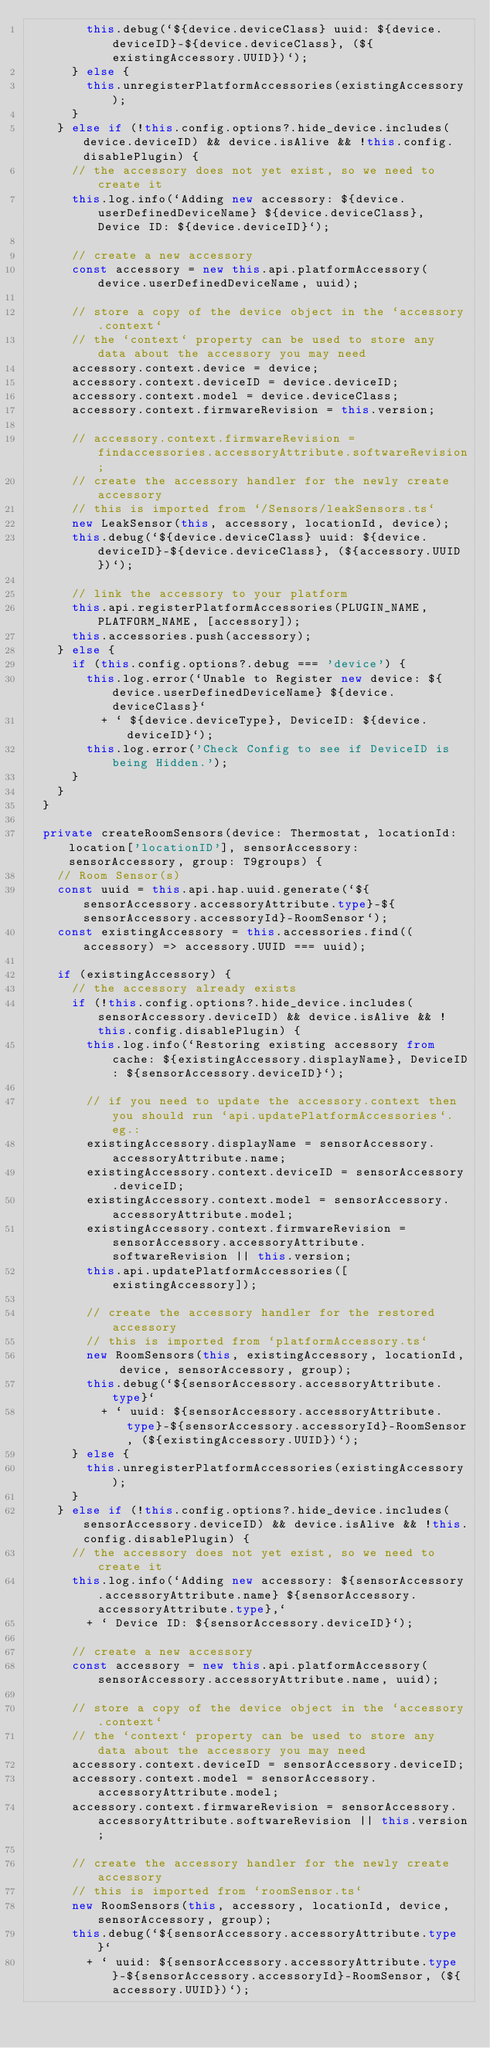<code> <loc_0><loc_0><loc_500><loc_500><_TypeScript_>        this.debug(`${device.deviceClass} uuid: ${device.deviceID}-${device.deviceClass}, (${existingAccessory.UUID})`);
      } else {
        this.unregisterPlatformAccessories(existingAccessory);
      }
    } else if (!this.config.options?.hide_device.includes(device.deviceID) && device.isAlive && !this.config.disablePlugin) {
      // the accessory does not yet exist, so we need to create it
      this.log.info(`Adding new accessory: ${device.userDefinedDeviceName} ${device.deviceClass}, Device ID: ${device.deviceID}`);

      // create a new accessory
      const accessory = new this.api.platformAccessory(device.userDefinedDeviceName, uuid);

      // store a copy of the device object in the `accessory.context`
      // the `context` property can be used to store any data about the accessory you may need
      accessory.context.device = device;
      accessory.context.deviceID = device.deviceID;
      accessory.context.model = device.deviceClass;
      accessory.context.firmwareRevision = this.version;

      // accessory.context.firmwareRevision = findaccessories.accessoryAttribute.softwareRevision;
      // create the accessory handler for the newly create accessory
      // this is imported from `/Sensors/leakSensors.ts`
      new LeakSensor(this, accessory, locationId, device);
      this.debug(`${device.deviceClass} uuid: ${device.deviceID}-${device.deviceClass}, (${accessory.UUID})`);

      // link the accessory to your platform
      this.api.registerPlatformAccessories(PLUGIN_NAME, PLATFORM_NAME, [accessory]);
      this.accessories.push(accessory);
    } else {
      if (this.config.options?.debug === 'device') {
        this.log.error(`Unable to Register new device: ${device.userDefinedDeviceName} ${device.deviceClass}`
          + ` ${device.deviceType}, DeviceID: ${device.deviceID}`);
        this.log.error('Check Config to see if DeviceID is being Hidden.');
      }
    }
  }

  private createRoomSensors(device: Thermostat, locationId: location['locationID'], sensorAccessory: sensorAccessory, group: T9groups) {
    // Room Sensor(s)
    const uuid = this.api.hap.uuid.generate(`${sensorAccessory.accessoryAttribute.type}-${sensorAccessory.accessoryId}-RoomSensor`);
    const existingAccessory = this.accessories.find((accessory) => accessory.UUID === uuid);

    if (existingAccessory) {
      // the accessory already exists
      if (!this.config.options?.hide_device.includes(sensorAccessory.deviceID) && device.isAlive && !this.config.disablePlugin) {
        this.log.info(`Restoring existing accessory from cache: ${existingAccessory.displayName}, DeviceID: ${sensorAccessory.deviceID}`);

        // if you need to update the accessory.context then you should run `api.updatePlatformAccessories`. eg.:
        existingAccessory.displayName = sensorAccessory.accessoryAttribute.name;
        existingAccessory.context.deviceID = sensorAccessory.deviceID;
        existingAccessory.context.model = sensorAccessory.accessoryAttribute.model;
        existingAccessory.context.firmwareRevision = sensorAccessory.accessoryAttribute.softwareRevision || this.version;
        this.api.updatePlatformAccessories([existingAccessory]);

        // create the accessory handler for the restored accessory
        // this is imported from `platformAccessory.ts`
        new RoomSensors(this, existingAccessory, locationId, device, sensorAccessory, group);
        this.debug(`${sensorAccessory.accessoryAttribute.type}`
          + ` uuid: ${sensorAccessory.accessoryAttribute.type}-${sensorAccessory.accessoryId}-RoomSensor, (${existingAccessory.UUID})`);
      } else {
        this.unregisterPlatformAccessories(existingAccessory);
      }
    } else if (!this.config.options?.hide_device.includes(sensorAccessory.deviceID) && device.isAlive && !this.config.disablePlugin) {
      // the accessory does not yet exist, so we need to create it
      this.log.info(`Adding new accessory: ${sensorAccessory.accessoryAttribute.name} ${sensorAccessory.accessoryAttribute.type},`
        + ` Device ID: ${sensorAccessory.deviceID}`);

      // create a new accessory
      const accessory = new this.api.platformAccessory(sensorAccessory.accessoryAttribute.name, uuid);

      // store a copy of the device object in the `accessory.context`
      // the `context` property can be used to store any data about the accessory you may need
      accessory.context.deviceID = sensorAccessory.deviceID;
      accessory.context.model = sensorAccessory.accessoryAttribute.model;
      accessory.context.firmwareRevision = sensorAccessory.accessoryAttribute.softwareRevision || this.version;

      // create the accessory handler for the newly create accessory
      // this is imported from `roomSensor.ts`
      new RoomSensors(this, accessory, locationId, device, sensorAccessory, group);
      this.debug(`${sensorAccessory.accessoryAttribute.type}`
        + ` uuid: ${sensorAccessory.accessoryAttribute.type}-${sensorAccessory.accessoryId}-RoomSensor, (${accessory.UUID})`);</code> 